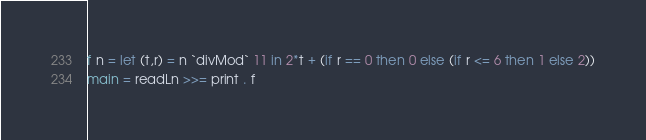<code> <loc_0><loc_0><loc_500><loc_500><_Haskell_>f n = let (t,r) = n `divMod` 11 in 2*t + (if r == 0 then 0 else (if r <= 6 then 1 else 2))
main = readLn >>= print . f</code> 